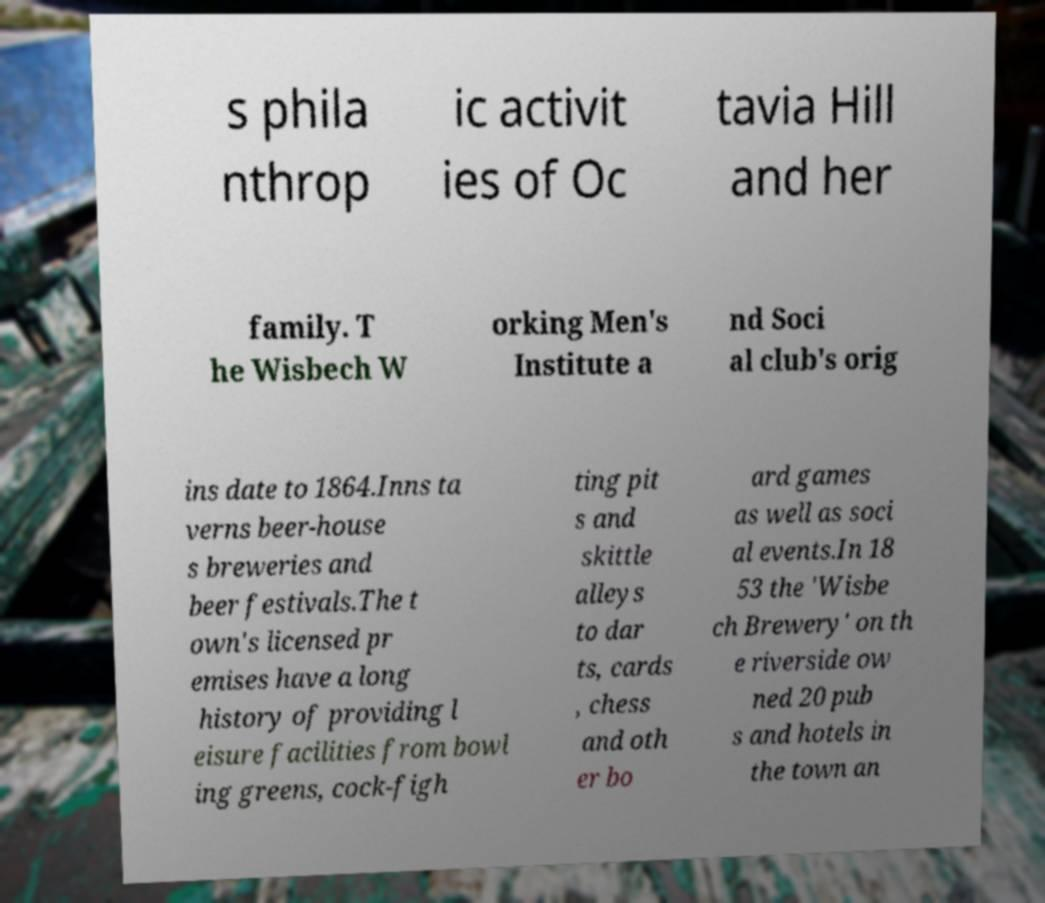For documentation purposes, I need the text within this image transcribed. Could you provide that? s phila nthrop ic activit ies of Oc tavia Hill and her family. T he Wisbech W orking Men's Institute a nd Soci al club's orig ins date to 1864.Inns ta verns beer-house s breweries and beer festivals.The t own's licensed pr emises have a long history of providing l eisure facilities from bowl ing greens, cock-figh ting pit s and skittle alleys to dar ts, cards , chess and oth er bo ard games as well as soci al events.In 18 53 the 'Wisbe ch Brewery' on th e riverside ow ned 20 pub s and hotels in the town an 